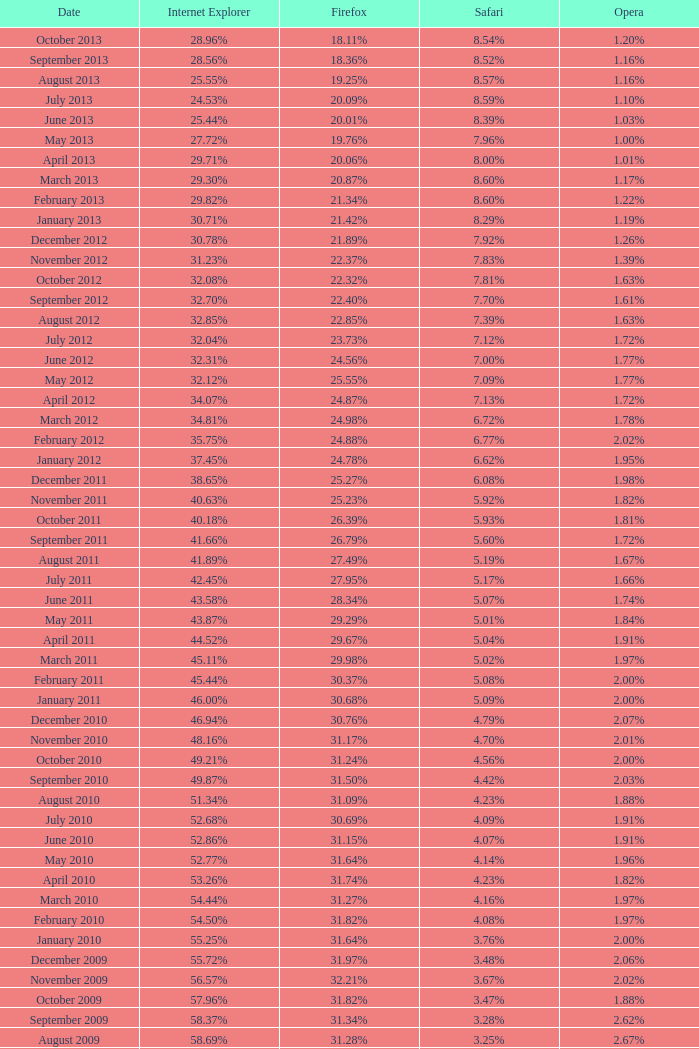What fraction of browsers were navigating with safari when 3 4.16%. 